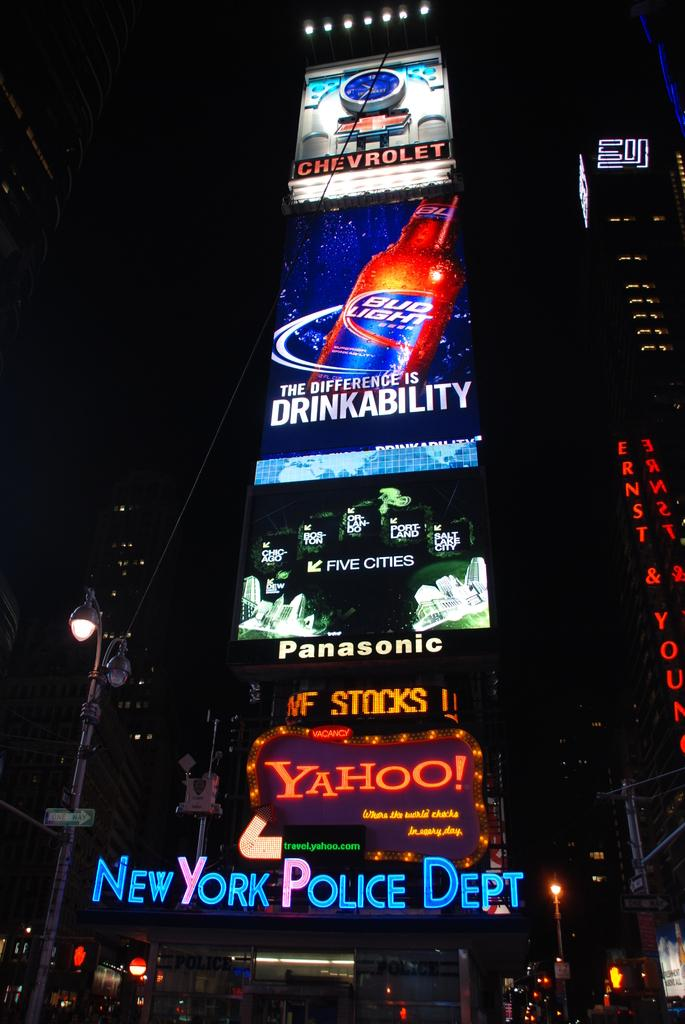<image>
Present a compact description of the photo's key features. billboards from new york city featuring yahoo, bud light, chevrolet, and panasonic 